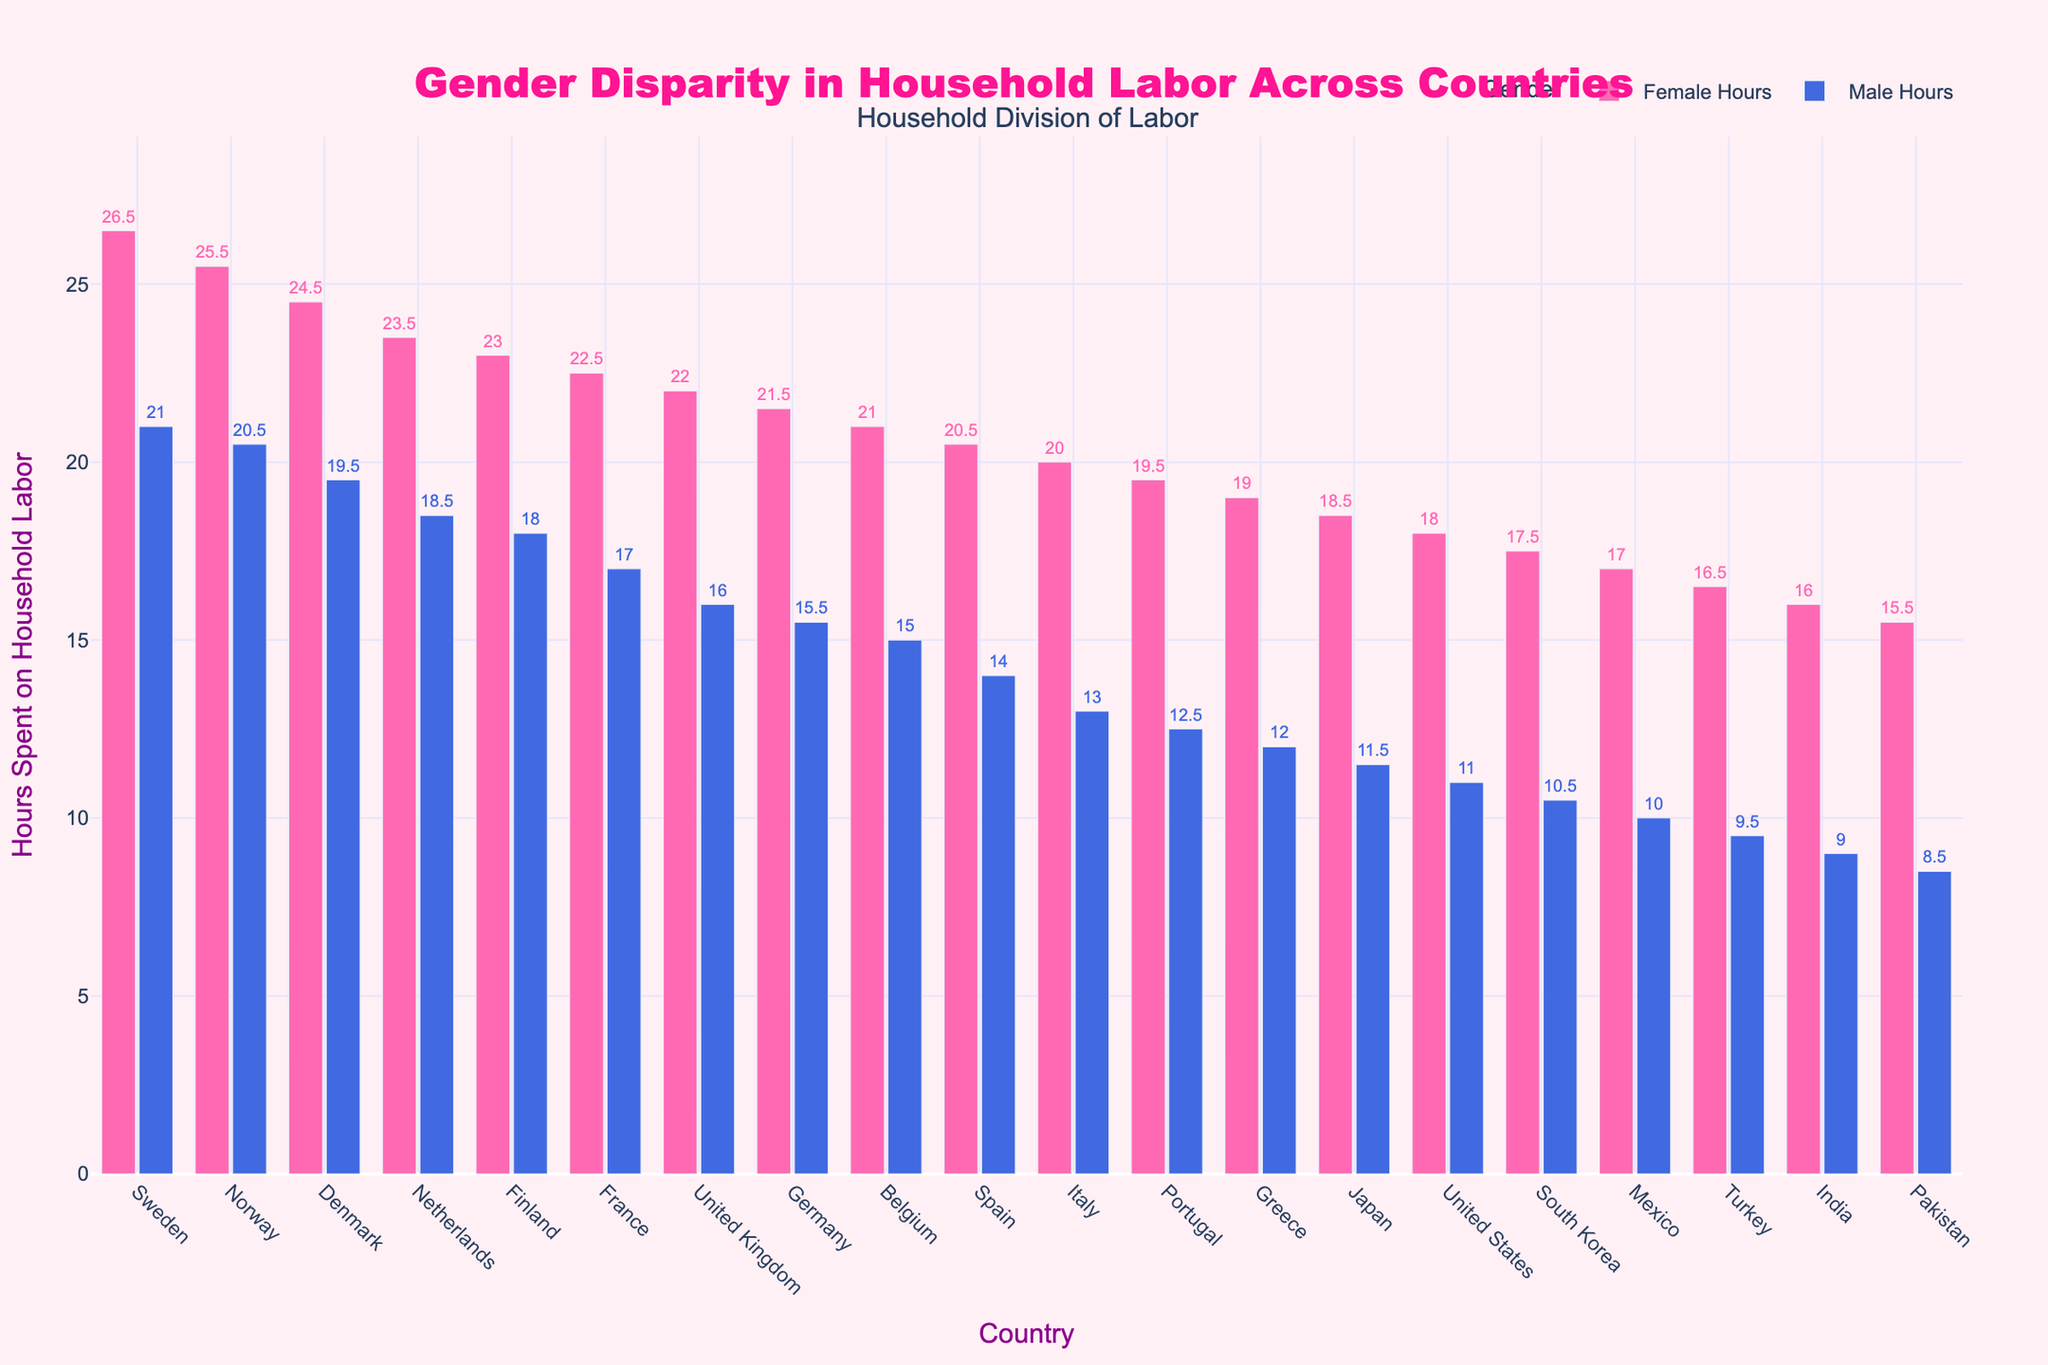What's the total number of hours spent on household labor by both genders in Sweden? To find the total number of hours spent on household labor by both genders in Sweden, add the hours spent by females and males: 26.5 (Female) + 21.0 (Male) = 47.5 hours.
Answer: 47.5 hours Which country shows the smallest difference in household labor hours between females and males? To identify the country with the smallest difference in household labor hours between genders, subtract male hours from female hours for each country and find the minimum difference. The country with the smallest difference is Norway: 25.5 (Female) - 20.5 (Male) = 5 hours.
Answer: Norway In which country do males spend the most hours on household labor? Look at the height of the bars representing male hours across all countries. The highest bar for males is in Sweden, where males spend 21.0 hours on household labor.
Answer: Sweden Compare the household labor hours difference between females and males in Pakistan and the United States. Which is larger? Calculate the difference in hours between females and males for both Pakistan and the United States. For Pakistan: 15.5 (Female) - 8.5 (Male) = 7 hours, and for the United States: 18.0 (Female) - 11.0 (Male) = 7 hours. Both differences are equal.
Answer: Equal Which countries have females spending more than 20 hours on household labor? Identify and list the countries where the female hours bar exceeds 20 hours. These countries are Sweden, Norway, Denmark, Netherlands, Finland, France, United Kingdom, Germany, Belgium, and Spain.
Answer: Sweden, Norway, Denmark, Netherlands, Finland, France, United Kingdom, Germany, Belgium, Spain Among the listed countries, which has the lowest number of hours spent on household labor by females? Find the shortest bar representing female hours among all countries. The shortest bar for females is in Pakistan, where females spend 15.5 hours on household labor.
Answer: Pakistan Between Germany and Mexico, which country has a smaller gap between female and male household labor hours? Calculate the difference in hours between females and males for Germany and Mexico. For Germany: 21.5 (Female) - 15.5 (Male) = 6 hours, and for Mexico: 17.0 (Female) - 10.0 (Male) = 7 hours. The smaller gap is in Germany.
Answer: Germany What is the average number of hours spent on household labor by males across all countries in the dataset? To find the average, sum the male hours for all countries and divide by the number of countries. Total male hours = 21.0 + 20.5 + 19.5 + 18.5 + 18.0 + 17.0 + 16.0 + 15.5 + 15.0 + 14.0 + 13.0 + 12.5 + 12.0 + 11.5 + 11.0 + 10.5 + 10.0 + 9.5 + 9.0 + 8.5 = 293. Total countries = 20. Average = 293 / 20 = 14.65 hours.
Answer: 14.65 hours Which country has the second highest female hours, and how many hours are spent? Find the country with the second highest bar for female hours. After Sweden (26.5 hours), the second highest is Norway with 25.5 hours.
Answer: Norway, 25.5 hours 